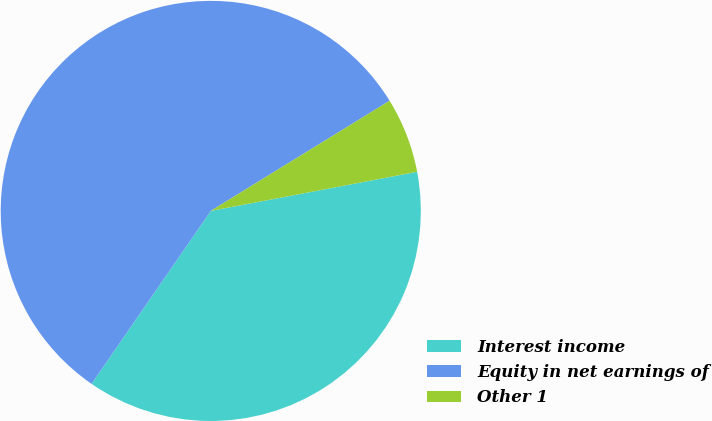Convert chart. <chart><loc_0><loc_0><loc_500><loc_500><pie_chart><fcel>Interest income<fcel>Equity in net earnings of<fcel>Other 1<nl><fcel>37.59%<fcel>56.61%<fcel>5.8%<nl></chart> 